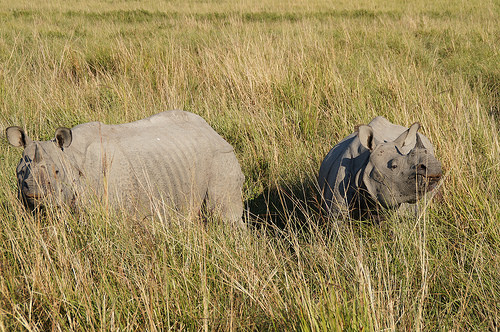<image>
Can you confirm if the rhino is behind the head? No. The rhino is not behind the head. From this viewpoint, the rhino appears to be positioned elsewhere in the scene. 